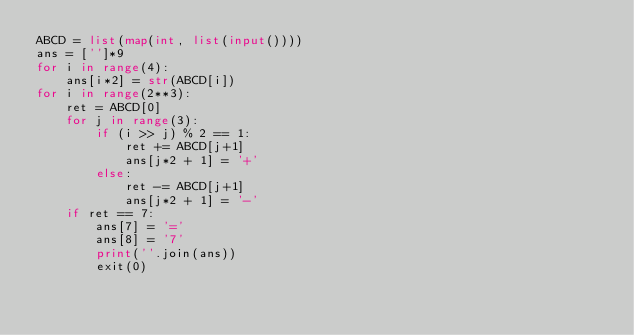<code> <loc_0><loc_0><loc_500><loc_500><_Python_>ABCD = list(map(int, list(input())))
ans = ['']*9
for i in range(4):
    ans[i*2] = str(ABCD[i])
for i in range(2**3):
    ret = ABCD[0]
    for j in range(3):
        if (i >> j) % 2 == 1:
            ret += ABCD[j+1]
            ans[j*2 + 1] = '+'
        else:
            ret -= ABCD[j+1]
            ans[j*2 + 1] = '-'
    if ret == 7:
        ans[7] = '='
        ans[8] = '7'
        print(''.join(ans))
        exit(0)
</code> 